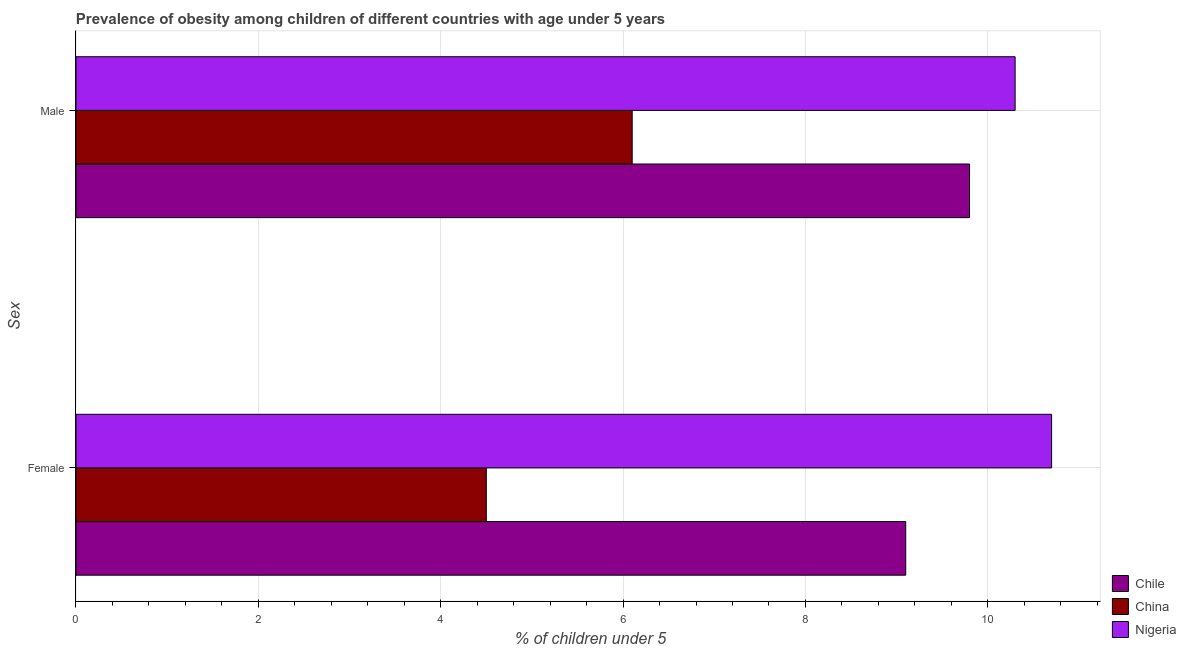How many different coloured bars are there?
Give a very brief answer. 3. Are the number of bars on each tick of the Y-axis equal?
Provide a short and direct response. Yes. How many bars are there on the 1st tick from the top?
Offer a terse response. 3. How many bars are there on the 2nd tick from the bottom?
Your response must be concise. 3. What is the label of the 2nd group of bars from the top?
Give a very brief answer. Female. What is the percentage of obese male children in Chile?
Ensure brevity in your answer.  9.8. Across all countries, what is the maximum percentage of obese female children?
Offer a terse response. 10.7. Across all countries, what is the minimum percentage of obese female children?
Give a very brief answer. 4.5. In which country was the percentage of obese male children maximum?
Your answer should be compact. Nigeria. In which country was the percentage of obese male children minimum?
Provide a succinct answer. China. What is the total percentage of obese male children in the graph?
Offer a very short reply. 26.2. What is the difference between the percentage of obese male children in Chile and that in China?
Give a very brief answer. 3.7. What is the difference between the percentage of obese male children in China and the percentage of obese female children in Chile?
Offer a terse response. -3. What is the average percentage of obese male children per country?
Provide a succinct answer. 8.73. What is the difference between the percentage of obese male children and percentage of obese female children in China?
Give a very brief answer. 1.6. In how many countries, is the percentage of obese male children greater than 10 %?
Your answer should be very brief. 1. What is the ratio of the percentage of obese female children in Nigeria to that in Chile?
Keep it short and to the point. 1.18. Is the percentage of obese female children in Chile less than that in China?
Your response must be concise. No. What does the 1st bar from the top in Male represents?
Provide a succinct answer. Nigeria. What does the 1st bar from the bottom in Female represents?
Offer a very short reply. Chile. Are all the bars in the graph horizontal?
Your answer should be very brief. Yes. How many countries are there in the graph?
Provide a short and direct response. 3. What is the difference between two consecutive major ticks on the X-axis?
Offer a very short reply. 2. Are the values on the major ticks of X-axis written in scientific E-notation?
Provide a short and direct response. No. Does the graph contain any zero values?
Keep it short and to the point. No. Does the graph contain grids?
Your answer should be very brief. Yes. Where does the legend appear in the graph?
Your response must be concise. Bottom right. How many legend labels are there?
Your answer should be compact. 3. How are the legend labels stacked?
Provide a short and direct response. Vertical. What is the title of the graph?
Your answer should be very brief. Prevalence of obesity among children of different countries with age under 5 years. Does "Djibouti" appear as one of the legend labels in the graph?
Ensure brevity in your answer.  No. What is the label or title of the X-axis?
Give a very brief answer.  % of children under 5. What is the label or title of the Y-axis?
Make the answer very short. Sex. What is the  % of children under 5 in Chile in Female?
Provide a succinct answer. 9.1. What is the  % of children under 5 of China in Female?
Provide a short and direct response. 4.5. What is the  % of children under 5 in Nigeria in Female?
Your answer should be very brief. 10.7. What is the  % of children under 5 of Chile in Male?
Provide a succinct answer. 9.8. What is the  % of children under 5 of China in Male?
Ensure brevity in your answer.  6.1. What is the  % of children under 5 in Nigeria in Male?
Your answer should be very brief. 10.3. Across all Sex, what is the maximum  % of children under 5 of Chile?
Offer a terse response. 9.8. Across all Sex, what is the maximum  % of children under 5 in China?
Your answer should be compact. 6.1. Across all Sex, what is the maximum  % of children under 5 in Nigeria?
Ensure brevity in your answer.  10.7. Across all Sex, what is the minimum  % of children under 5 in Chile?
Provide a succinct answer. 9.1. Across all Sex, what is the minimum  % of children under 5 in China?
Keep it short and to the point. 4.5. Across all Sex, what is the minimum  % of children under 5 of Nigeria?
Offer a very short reply. 10.3. What is the total  % of children under 5 of China in the graph?
Your answer should be very brief. 10.6. What is the difference between the  % of children under 5 in China in Female and the  % of children under 5 in Nigeria in Male?
Provide a succinct answer. -5.8. What is the average  % of children under 5 in Chile per Sex?
Ensure brevity in your answer.  9.45. What is the average  % of children under 5 in China per Sex?
Make the answer very short. 5.3. What is the average  % of children under 5 in Nigeria per Sex?
Provide a short and direct response. 10.5. What is the difference between the  % of children under 5 in Chile and  % of children under 5 in China in Female?
Give a very brief answer. 4.6. What is the difference between the  % of children under 5 in China and  % of children under 5 in Nigeria in Female?
Ensure brevity in your answer.  -6.2. What is the difference between the  % of children under 5 of Chile and  % of children under 5 of China in Male?
Your answer should be compact. 3.7. What is the difference between the  % of children under 5 of China and  % of children under 5 of Nigeria in Male?
Provide a short and direct response. -4.2. What is the ratio of the  % of children under 5 in Chile in Female to that in Male?
Provide a succinct answer. 0.93. What is the ratio of the  % of children under 5 in China in Female to that in Male?
Provide a short and direct response. 0.74. What is the ratio of the  % of children under 5 in Nigeria in Female to that in Male?
Make the answer very short. 1.04. What is the difference between the highest and the second highest  % of children under 5 of Chile?
Offer a terse response. 0.7. What is the difference between the highest and the second highest  % of children under 5 in China?
Provide a succinct answer. 1.6. What is the difference between the highest and the second highest  % of children under 5 of Nigeria?
Make the answer very short. 0.4. What is the difference between the highest and the lowest  % of children under 5 in Nigeria?
Make the answer very short. 0.4. 